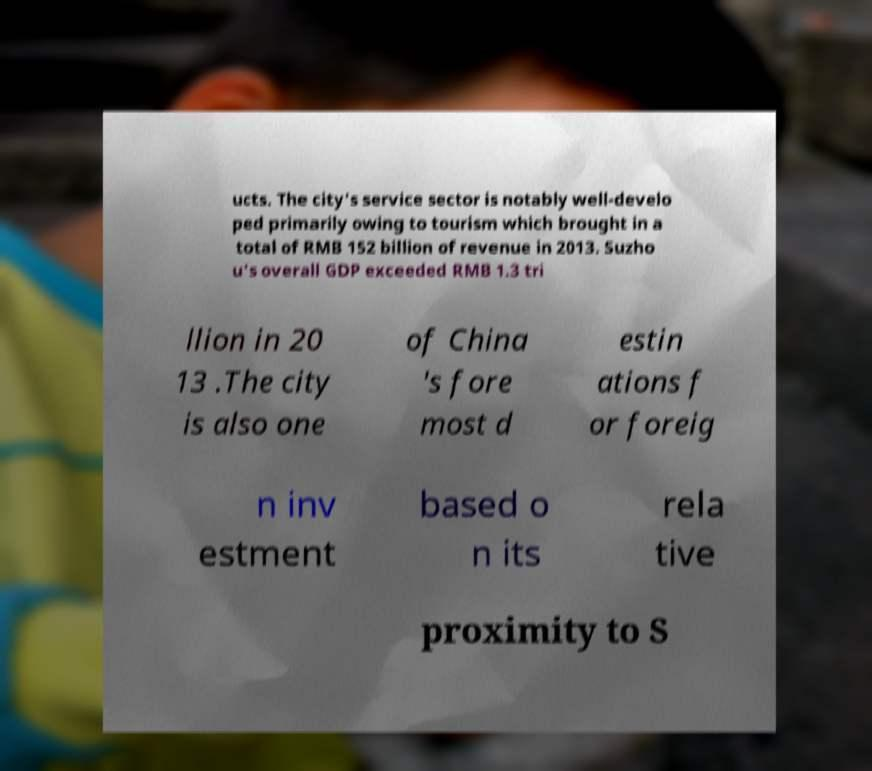Please read and relay the text visible in this image. What does it say? ucts. The city's service sector is notably well-develo ped primarily owing to tourism which brought in a total of RMB 152 billion of revenue in 2013. Suzho u's overall GDP exceeded RMB 1.3 tri llion in 20 13 .The city is also one of China 's fore most d estin ations f or foreig n inv estment based o n its rela tive proximity to S 